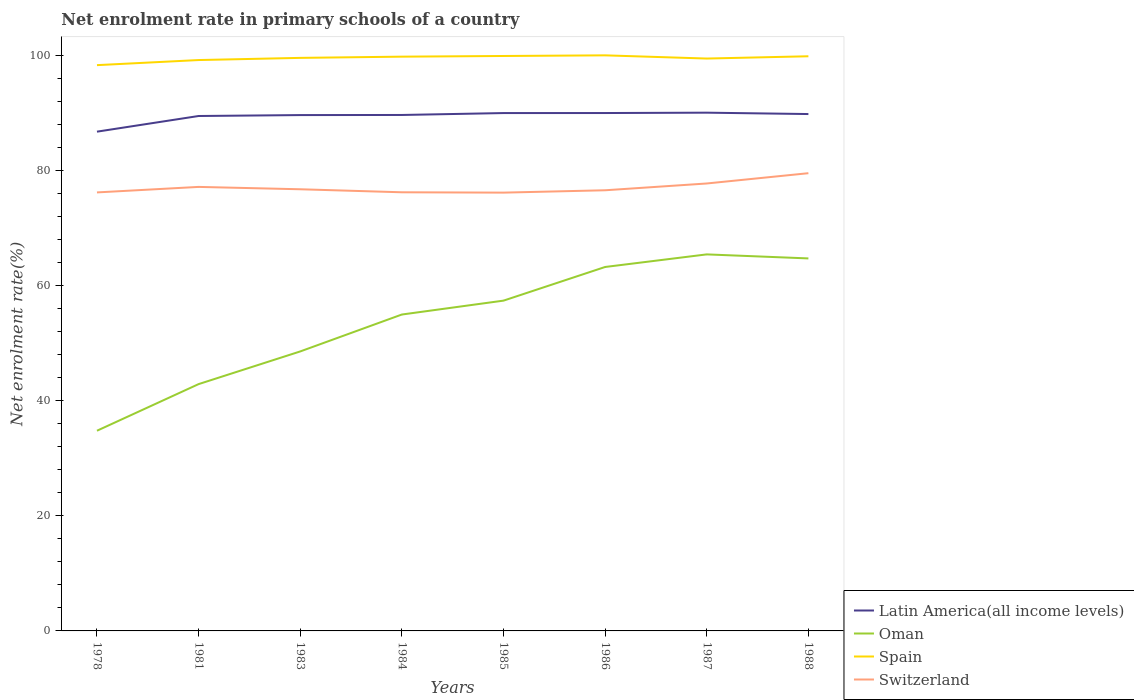Does the line corresponding to Switzerland intersect with the line corresponding to Latin America(all income levels)?
Provide a short and direct response. No. Across all years, what is the maximum net enrolment rate in primary schools in Spain?
Provide a short and direct response. 98.29. In which year was the net enrolment rate in primary schools in Spain maximum?
Offer a very short reply. 1978. What is the total net enrolment rate in primary schools in Switzerland in the graph?
Provide a short and direct response. -0.35. What is the difference between the highest and the second highest net enrolment rate in primary schools in Switzerland?
Provide a short and direct response. 3.38. What is the difference between the highest and the lowest net enrolment rate in primary schools in Switzerland?
Your answer should be very brief. 3. Is the net enrolment rate in primary schools in Spain strictly greater than the net enrolment rate in primary schools in Switzerland over the years?
Your answer should be very brief. No. How many lines are there?
Make the answer very short. 4. How many years are there in the graph?
Your response must be concise. 8. Does the graph contain any zero values?
Offer a terse response. No. Where does the legend appear in the graph?
Provide a short and direct response. Bottom right. What is the title of the graph?
Make the answer very short. Net enrolment rate in primary schools of a country. Does "Guinea" appear as one of the legend labels in the graph?
Your response must be concise. No. What is the label or title of the X-axis?
Offer a very short reply. Years. What is the label or title of the Y-axis?
Give a very brief answer. Net enrolment rate(%). What is the Net enrolment rate(%) of Latin America(all income levels) in 1978?
Give a very brief answer. 86.74. What is the Net enrolment rate(%) of Oman in 1978?
Offer a very short reply. 34.78. What is the Net enrolment rate(%) in Spain in 1978?
Provide a short and direct response. 98.29. What is the Net enrolment rate(%) in Switzerland in 1978?
Your answer should be very brief. 76.18. What is the Net enrolment rate(%) in Latin America(all income levels) in 1981?
Your answer should be compact. 89.46. What is the Net enrolment rate(%) of Oman in 1981?
Your answer should be very brief. 42.88. What is the Net enrolment rate(%) in Spain in 1981?
Ensure brevity in your answer.  99.18. What is the Net enrolment rate(%) of Switzerland in 1981?
Keep it short and to the point. 77.14. What is the Net enrolment rate(%) of Latin America(all income levels) in 1983?
Your answer should be compact. 89.62. What is the Net enrolment rate(%) in Oman in 1983?
Ensure brevity in your answer.  48.55. What is the Net enrolment rate(%) in Spain in 1983?
Your response must be concise. 99.56. What is the Net enrolment rate(%) in Switzerland in 1983?
Your response must be concise. 76.73. What is the Net enrolment rate(%) in Latin America(all income levels) in 1984?
Provide a short and direct response. 89.64. What is the Net enrolment rate(%) of Oman in 1984?
Offer a very short reply. 54.97. What is the Net enrolment rate(%) of Spain in 1984?
Give a very brief answer. 99.77. What is the Net enrolment rate(%) of Switzerland in 1984?
Give a very brief answer. 76.21. What is the Net enrolment rate(%) of Latin America(all income levels) in 1985?
Provide a succinct answer. 89.97. What is the Net enrolment rate(%) of Oman in 1985?
Offer a very short reply. 57.38. What is the Net enrolment rate(%) of Spain in 1985?
Ensure brevity in your answer.  99.89. What is the Net enrolment rate(%) in Switzerland in 1985?
Keep it short and to the point. 76.15. What is the Net enrolment rate(%) of Latin America(all income levels) in 1986?
Offer a very short reply. 89.98. What is the Net enrolment rate(%) in Oman in 1986?
Make the answer very short. 63.23. What is the Net enrolment rate(%) of Spain in 1986?
Make the answer very short. 100. What is the Net enrolment rate(%) in Switzerland in 1986?
Your answer should be compact. 76.56. What is the Net enrolment rate(%) of Latin America(all income levels) in 1987?
Ensure brevity in your answer.  90.04. What is the Net enrolment rate(%) in Oman in 1987?
Your answer should be very brief. 65.42. What is the Net enrolment rate(%) in Spain in 1987?
Provide a short and direct response. 99.44. What is the Net enrolment rate(%) in Switzerland in 1987?
Provide a short and direct response. 77.74. What is the Net enrolment rate(%) of Latin America(all income levels) in 1988?
Your answer should be very brief. 89.8. What is the Net enrolment rate(%) of Oman in 1988?
Offer a very short reply. 64.72. What is the Net enrolment rate(%) of Spain in 1988?
Ensure brevity in your answer.  99.84. What is the Net enrolment rate(%) of Switzerland in 1988?
Your answer should be compact. 79.52. Across all years, what is the maximum Net enrolment rate(%) of Latin America(all income levels)?
Your answer should be compact. 90.04. Across all years, what is the maximum Net enrolment rate(%) of Oman?
Provide a short and direct response. 65.42. Across all years, what is the maximum Net enrolment rate(%) in Spain?
Give a very brief answer. 100. Across all years, what is the maximum Net enrolment rate(%) in Switzerland?
Give a very brief answer. 79.52. Across all years, what is the minimum Net enrolment rate(%) of Latin America(all income levels)?
Provide a succinct answer. 86.74. Across all years, what is the minimum Net enrolment rate(%) in Oman?
Ensure brevity in your answer.  34.78. Across all years, what is the minimum Net enrolment rate(%) in Spain?
Offer a very short reply. 98.29. Across all years, what is the minimum Net enrolment rate(%) in Switzerland?
Your response must be concise. 76.15. What is the total Net enrolment rate(%) of Latin America(all income levels) in the graph?
Ensure brevity in your answer.  715.24. What is the total Net enrolment rate(%) in Oman in the graph?
Offer a very short reply. 431.93. What is the total Net enrolment rate(%) in Spain in the graph?
Keep it short and to the point. 795.97. What is the total Net enrolment rate(%) in Switzerland in the graph?
Provide a short and direct response. 616.22. What is the difference between the Net enrolment rate(%) in Latin America(all income levels) in 1978 and that in 1981?
Keep it short and to the point. -2.72. What is the difference between the Net enrolment rate(%) in Oman in 1978 and that in 1981?
Offer a terse response. -8.1. What is the difference between the Net enrolment rate(%) of Spain in 1978 and that in 1981?
Provide a succinct answer. -0.89. What is the difference between the Net enrolment rate(%) of Switzerland in 1978 and that in 1981?
Your answer should be very brief. -0.96. What is the difference between the Net enrolment rate(%) in Latin America(all income levels) in 1978 and that in 1983?
Provide a short and direct response. -2.88. What is the difference between the Net enrolment rate(%) in Oman in 1978 and that in 1983?
Make the answer very short. -13.78. What is the difference between the Net enrolment rate(%) in Spain in 1978 and that in 1983?
Your answer should be compact. -1.26. What is the difference between the Net enrolment rate(%) of Switzerland in 1978 and that in 1983?
Make the answer very short. -0.55. What is the difference between the Net enrolment rate(%) in Latin America(all income levels) in 1978 and that in 1984?
Make the answer very short. -2.9. What is the difference between the Net enrolment rate(%) of Oman in 1978 and that in 1984?
Your response must be concise. -20.19. What is the difference between the Net enrolment rate(%) of Spain in 1978 and that in 1984?
Give a very brief answer. -1.48. What is the difference between the Net enrolment rate(%) in Switzerland in 1978 and that in 1984?
Your response must be concise. -0.02. What is the difference between the Net enrolment rate(%) in Latin America(all income levels) in 1978 and that in 1985?
Ensure brevity in your answer.  -3.23. What is the difference between the Net enrolment rate(%) in Oman in 1978 and that in 1985?
Offer a very short reply. -22.6. What is the difference between the Net enrolment rate(%) of Spain in 1978 and that in 1985?
Make the answer very short. -1.59. What is the difference between the Net enrolment rate(%) of Switzerland in 1978 and that in 1985?
Your response must be concise. 0.04. What is the difference between the Net enrolment rate(%) in Latin America(all income levels) in 1978 and that in 1986?
Provide a succinct answer. -3.24. What is the difference between the Net enrolment rate(%) in Oman in 1978 and that in 1986?
Your answer should be very brief. -28.45. What is the difference between the Net enrolment rate(%) of Spain in 1978 and that in 1986?
Give a very brief answer. -1.7. What is the difference between the Net enrolment rate(%) in Switzerland in 1978 and that in 1986?
Provide a succinct answer. -0.37. What is the difference between the Net enrolment rate(%) in Latin America(all income levels) in 1978 and that in 1987?
Provide a short and direct response. -3.3. What is the difference between the Net enrolment rate(%) in Oman in 1978 and that in 1987?
Provide a short and direct response. -30.64. What is the difference between the Net enrolment rate(%) in Spain in 1978 and that in 1987?
Offer a very short reply. -1.15. What is the difference between the Net enrolment rate(%) in Switzerland in 1978 and that in 1987?
Ensure brevity in your answer.  -1.55. What is the difference between the Net enrolment rate(%) in Latin America(all income levels) in 1978 and that in 1988?
Your answer should be compact. -3.06. What is the difference between the Net enrolment rate(%) of Oman in 1978 and that in 1988?
Provide a short and direct response. -29.94. What is the difference between the Net enrolment rate(%) of Spain in 1978 and that in 1988?
Make the answer very short. -1.54. What is the difference between the Net enrolment rate(%) of Switzerland in 1978 and that in 1988?
Offer a very short reply. -3.34. What is the difference between the Net enrolment rate(%) of Latin America(all income levels) in 1981 and that in 1983?
Keep it short and to the point. -0.16. What is the difference between the Net enrolment rate(%) of Oman in 1981 and that in 1983?
Your answer should be compact. -5.68. What is the difference between the Net enrolment rate(%) in Spain in 1981 and that in 1983?
Your answer should be very brief. -0.38. What is the difference between the Net enrolment rate(%) in Switzerland in 1981 and that in 1983?
Provide a succinct answer. 0.41. What is the difference between the Net enrolment rate(%) of Latin America(all income levels) in 1981 and that in 1984?
Offer a terse response. -0.18. What is the difference between the Net enrolment rate(%) of Oman in 1981 and that in 1984?
Provide a succinct answer. -12.09. What is the difference between the Net enrolment rate(%) of Spain in 1981 and that in 1984?
Your answer should be very brief. -0.59. What is the difference between the Net enrolment rate(%) of Switzerland in 1981 and that in 1984?
Your response must be concise. 0.93. What is the difference between the Net enrolment rate(%) of Latin America(all income levels) in 1981 and that in 1985?
Your answer should be compact. -0.51. What is the difference between the Net enrolment rate(%) in Oman in 1981 and that in 1985?
Your response must be concise. -14.5. What is the difference between the Net enrolment rate(%) in Spain in 1981 and that in 1985?
Offer a very short reply. -0.71. What is the difference between the Net enrolment rate(%) of Switzerland in 1981 and that in 1985?
Provide a succinct answer. 0.99. What is the difference between the Net enrolment rate(%) in Latin America(all income levels) in 1981 and that in 1986?
Give a very brief answer. -0.52. What is the difference between the Net enrolment rate(%) of Oman in 1981 and that in 1986?
Provide a succinct answer. -20.35. What is the difference between the Net enrolment rate(%) of Spain in 1981 and that in 1986?
Your answer should be compact. -0.82. What is the difference between the Net enrolment rate(%) in Switzerland in 1981 and that in 1986?
Provide a succinct answer. 0.58. What is the difference between the Net enrolment rate(%) in Latin America(all income levels) in 1981 and that in 1987?
Provide a short and direct response. -0.58. What is the difference between the Net enrolment rate(%) in Oman in 1981 and that in 1987?
Keep it short and to the point. -22.54. What is the difference between the Net enrolment rate(%) of Spain in 1981 and that in 1987?
Offer a very short reply. -0.26. What is the difference between the Net enrolment rate(%) in Switzerland in 1981 and that in 1987?
Keep it short and to the point. -0.6. What is the difference between the Net enrolment rate(%) of Latin America(all income levels) in 1981 and that in 1988?
Make the answer very short. -0.34. What is the difference between the Net enrolment rate(%) in Oman in 1981 and that in 1988?
Your response must be concise. -21.84. What is the difference between the Net enrolment rate(%) in Spain in 1981 and that in 1988?
Make the answer very short. -0.66. What is the difference between the Net enrolment rate(%) in Switzerland in 1981 and that in 1988?
Make the answer very short. -2.38. What is the difference between the Net enrolment rate(%) of Latin America(all income levels) in 1983 and that in 1984?
Your answer should be very brief. -0.02. What is the difference between the Net enrolment rate(%) of Oman in 1983 and that in 1984?
Offer a very short reply. -6.41. What is the difference between the Net enrolment rate(%) of Spain in 1983 and that in 1984?
Offer a very short reply. -0.21. What is the difference between the Net enrolment rate(%) in Switzerland in 1983 and that in 1984?
Provide a succinct answer. 0.52. What is the difference between the Net enrolment rate(%) in Latin America(all income levels) in 1983 and that in 1985?
Your answer should be very brief. -0.35. What is the difference between the Net enrolment rate(%) in Oman in 1983 and that in 1985?
Make the answer very short. -8.83. What is the difference between the Net enrolment rate(%) in Spain in 1983 and that in 1985?
Ensure brevity in your answer.  -0.33. What is the difference between the Net enrolment rate(%) in Switzerland in 1983 and that in 1985?
Give a very brief answer. 0.58. What is the difference between the Net enrolment rate(%) of Latin America(all income levels) in 1983 and that in 1986?
Your response must be concise. -0.36. What is the difference between the Net enrolment rate(%) in Oman in 1983 and that in 1986?
Provide a succinct answer. -14.67. What is the difference between the Net enrolment rate(%) of Spain in 1983 and that in 1986?
Ensure brevity in your answer.  -0.44. What is the difference between the Net enrolment rate(%) in Switzerland in 1983 and that in 1986?
Ensure brevity in your answer.  0.18. What is the difference between the Net enrolment rate(%) in Latin America(all income levels) in 1983 and that in 1987?
Your answer should be very brief. -0.42. What is the difference between the Net enrolment rate(%) of Oman in 1983 and that in 1987?
Keep it short and to the point. -16.86. What is the difference between the Net enrolment rate(%) in Spain in 1983 and that in 1987?
Offer a very short reply. 0.12. What is the difference between the Net enrolment rate(%) of Switzerland in 1983 and that in 1987?
Provide a succinct answer. -1. What is the difference between the Net enrolment rate(%) of Latin America(all income levels) in 1983 and that in 1988?
Your answer should be very brief. -0.18. What is the difference between the Net enrolment rate(%) of Oman in 1983 and that in 1988?
Your answer should be very brief. -16.16. What is the difference between the Net enrolment rate(%) in Spain in 1983 and that in 1988?
Give a very brief answer. -0.28. What is the difference between the Net enrolment rate(%) of Switzerland in 1983 and that in 1988?
Keep it short and to the point. -2.79. What is the difference between the Net enrolment rate(%) of Latin America(all income levels) in 1984 and that in 1985?
Your response must be concise. -0.33. What is the difference between the Net enrolment rate(%) of Oman in 1984 and that in 1985?
Give a very brief answer. -2.41. What is the difference between the Net enrolment rate(%) of Spain in 1984 and that in 1985?
Give a very brief answer. -0.12. What is the difference between the Net enrolment rate(%) of Switzerland in 1984 and that in 1985?
Your response must be concise. 0.06. What is the difference between the Net enrolment rate(%) of Latin America(all income levels) in 1984 and that in 1986?
Your response must be concise. -0.34. What is the difference between the Net enrolment rate(%) of Oman in 1984 and that in 1986?
Ensure brevity in your answer.  -8.26. What is the difference between the Net enrolment rate(%) in Spain in 1984 and that in 1986?
Ensure brevity in your answer.  -0.23. What is the difference between the Net enrolment rate(%) in Switzerland in 1984 and that in 1986?
Offer a terse response. -0.35. What is the difference between the Net enrolment rate(%) of Latin America(all income levels) in 1984 and that in 1987?
Offer a very short reply. -0.4. What is the difference between the Net enrolment rate(%) of Oman in 1984 and that in 1987?
Ensure brevity in your answer.  -10.45. What is the difference between the Net enrolment rate(%) of Spain in 1984 and that in 1987?
Provide a succinct answer. 0.33. What is the difference between the Net enrolment rate(%) in Switzerland in 1984 and that in 1987?
Your answer should be compact. -1.53. What is the difference between the Net enrolment rate(%) of Latin America(all income levels) in 1984 and that in 1988?
Your answer should be compact. -0.16. What is the difference between the Net enrolment rate(%) in Oman in 1984 and that in 1988?
Your response must be concise. -9.75. What is the difference between the Net enrolment rate(%) in Spain in 1984 and that in 1988?
Provide a succinct answer. -0.07. What is the difference between the Net enrolment rate(%) in Switzerland in 1984 and that in 1988?
Ensure brevity in your answer.  -3.32. What is the difference between the Net enrolment rate(%) of Latin America(all income levels) in 1985 and that in 1986?
Ensure brevity in your answer.  -0. What is the difference between the Net enrolment rate(%) of Oman in 1985 and that in 1986?
Your answer should be compact. -5.85. What is the difference between the Net enrolment rate(%) of Spain in 1985 and that in 1986?
Offer a terse response. -0.11. What is the difference between the Net enrolment rate(%) of Switzerland in 1985 and that in 1986?
Provide a short and direct response. -0.41. What is the difference between the Net enrolment rate(%) of Latin America(all income levels) in 1985 and that in 1987?
Give a very brief answer. -0.07. What is the difference between the Net enrolment rate(%) of Oman in 1985 and that in 1987?
Give a very brief answer. -8.04. What is the difference between the Net enrolment rate(%) in Spain in 1985 and that in 1987?
Provide a succinct answer. 0.45. What is the difference between the Net enrolment rate(%) in Switzerland in 1985 and that in 1987?
Keep it short and to the point. -1.59. What is the difference between the Net enrolment rate(%) in Latin America(all income levels) in 1985 and that in 1988?
Keep it short and to the point. 0.17. What is the difference between the Net enrolment rate(%) of Oman in 1985 and that in 1988?
Your response must be concise. -7.34. What is the difference between the Net enrolment rate(%) in Spain in 1985 and that in 1988?
Keep it short and to the point. 0.05. What is the difference between the Net enrolment rate(%) in Switzerland in 1985 and that in 1988?
Offer a terse response. -3.38. What is the difference between the Net enrolment rate(%) in Latin America(all income levels) in 1986 and that in 1987?
Your answer should be compact. -0.06. What is the difference between the Net enrolment rate(%) in Oman in 1986 and that in 1987?
Provide a succinct answer. -2.19. What is the difference between the Net enrolment rate(%) in Spain in 1986 and that in 1987?
Your answer should be very brief. 0.56. What is the difference between the Net enrolment rate(%) of Switzerland in 1986 and that in 1987?
Give a very brief answer. -1.18. What is the difference between the Net enrolment rate(%) in Latin America(all income levels) in 1986 and that in 1988?
Provide a succinct answer. 0.18. What is the difference between the Net enrolment rate(%) in Oman in 1986 and that in 1988?
Your response must be concise. -1.49. What is the difference between the Net enrolment rate(%) of Spain in 1986 and that in 1988?
Ensure brevity in your answer.  0.16. What is the difference between the Net enrolment rate(%) in Switzerland in 1986 and that in 1988?
Your response must be concise. -2.97. What is the difference between the Net enrolment rate(%) in Latin America(all income levels) in 1987 and that in 1988?
Provide a succinct answer. 0.24. What is the difference between the Net enrolment rate(%) in Oman in 1987 and that in 1988?
Your answer should be compact. 0.7. What is the difference between the Net enrolment rate(%) in Spain in 1987 and that in 1988?
Provide a succinct answer. -0.4. What is the difference between the Net enrolment rate(%) of Switzerland in 1987 and that in 1988?
Give a very brief answer. -1.79. What is the difference between the Net enrolment rate(%) in Latin America(all income levels) in 1978 and the Net enrolment rate(%) in Oman in 1981?
Provide a short and direct response. 43.86. What is the difference between the Net enrolment rate(%) of Latin America(all income levels) in 1978 and the Net enrolment rate(%) of Spain in 1981?
Your answer should be compact. -12.44. What is the difference between the Net enrolment rate(%) of Latin America(all income levels) in 1978 and the Net enrolment rate(%) of Switzerland in 1981?
Give a very brief answer. 9.6. What is the difference between the Net enrolment rate(%) in Oman in 1978 and the Net enrolment rate(%) in Spain in 1981?
Provide a succinct answer. -64.4. What is the difference between the Net enrolment rate(%) of Oman in 1978 and the Net enrolment rate(%) of Switzerland in 1981?
Your answer should be very brief. -42.36. What is the difference between the Net enrolment rate(%) in Spain in 1978 and the Net enrolment rate(%) in Switzerland in 1981?
Your response must be concise. 21.16. What is the difference between the Net enrolment rate(%) in Latin America(all income levels) in 1978 and the Net enrolment rate(%) in Oman in 1983?
Provide a short and direct response. 38.18. What is the difference between the Net enrolment rate(%) in Latin America(all income levels) in 1978 and the Net enrolment rate(%) in Spain in 1983?
Offer a very short reply. -12.82. What is the difference between the Net enrolment rate(%) of Latin America(all income levels) in 1978 and the Net enrolment rate(%) of Switzerland in 1983?
Offer a very short reply. 10.01. What is the difference between the Net enrolment rate(%) in Oman in 1978 and the Net enrolment rate(%) in Spain in 1983?
Keep it short and to the point. -64.78. What is the difference between the Net enrolment rate(%) in Oman in 1978 and the Net enrolment rate(%) in Switzerland in 1983?
Keep it short and to the point. -41.95. What is the difference between the Net enrolment rate(%) of Spain in 1978 and the Net enrolment rate(%) of Switzerland in 1983?
Give a very brief answer. 21.56. What is the difference between the Net enrolment rate(%) in Latin America(all income levels) in 1978 and the Net enrolment rate(%) in Oman in 1984?
Your response must be concise. 31.77. What is the difference between the Net enrolment rate(%) of Latin America(all income levels) in 1978 and the Net enrolment rate(%) of Spain in 1984?
Your response must be concise. -13.03. What is the difference between the Net enrolment rate(%) in Latin America(all income levels) in 1978 and the Net enrolment rate(%) in Switzerland in 1984?
Your answer should be very brief. 10.53. What is the difference between the Net enrolment rate(%) of Oman in 1978 and the Net enrolment rate(%) of Spain in 1984?
Provide a short and direct response. -64.99. What is the difference between the Net enrolment rate(%) in Oman in 1978 and the Net enrolment rate(%) in Switzerland in 1984?
Ensure brevity in your answer.  -41.43. What is the difference between the Net enrolment rate(%) in Spain in 1978 and the Net enrolment rate(%) in Switzerland in 1984?
Offer a very short reply. 22.09. What is the difference between the Net enrolment rate(%) of Latin America(all income levels) in 1978 and the Net enrolment rate(%) of Oman in 1985?
Give a very brief answer. 29.36. What is the difference between the Net enrolment rate(%) of Latin America(all income levels) in 1978 and the Net enrolment rate(%) of Spain in 1985?
Give a very brief answer. -13.15. What is the difference between the Net enrolment rate(%) of Latin America(all income levels) in 1978 and the Net enrolment rate(%) of Switzerland in 1985?
Make the answer very short. 10.59. What is the difference between the Net enrolment rate(%) of Oman in 1978 and the Net enrolment rate(%) of Spain in 1985?
Make the answer very short. -65.11. What is the difference between the Net enrolment rate(%) in Oman in 1978 and the Net enrolment rate(%) in Switzerland in 1985?
Ensure brevity in your answer.  -41.37. What is the difference between the Net enrolment rate(%) of Spain in 1978 and the Net enrolment rate(%) of Switzerland in 1985?
Give a very brief answer. 22.15. What is the difference between the Net enrolment rate(%) of Latin America(all income levels) in 1978 and the Net enrolment rate(%) of Oman in 1986?
Your response must be concise. 23.51. What is the difference between the Net enrolment rate(%) of Latin America(all income levels) in 1978 and the Net enrolment rate(%) of Spain in 1986?
Make the answer very short. -13.26. What is the difference between the Net enrolment rate(%) of Latin America(all income levels) in 1978 and the Net enrolment rate(%) of Switzerland in 1986?
Keep it short and to the point. 10.18. What is the difference between the Net enrolment rate(%) of Oman in 1978 and the Net enrolment rate(%) of Spain in 1986?
Your response must be concise. -65.22. What is the difference between the Net enrolment rate(%) in Oman in 1978 and the Net enrolment rate(%) in Switzerland in 1986?
Give a very brief answer. -41.78. What is the difference between the Net enrolment rate(%) in Spain in 1978 and the Net enrolment rate(%) in Switzerland in 1986?
Ensure brevity in your answer.  21.74. What is the difference between the Net enrolment rate(%) in Latin America(all income levels) in 1978 and the Net enrolment rate(%) in Oman in 1987?
Your answer should be very brief. 21.32. What is the difference between the Net enrolment rate(%) of Latin America(all income levels) in 1978 and the Net enrolment rate(%) of Spain in 1987?
Your response must be concise. -12.7. What is the difference between the Net enrolment rate(%) of Latin America(all income levels) in 1978 and the Net enrolment rate(%) of Switzerland in 1987?
Provide a succinct answer. 9. What is the difference between the Net enrolment rate(%) in Oman in 1978 and the Net enrolment rate(%) in Spain in 1987?
Provide a succinct answer. -64.66. What is the difference between the Net enrolment rate(%) in Oman in 1978 and the Net enrolment rate(%) in Switzerland in 1987?
Make the answer very short. -42.96. What is the difference between the Net enrolment rate(%) of Spain in 1978 and the Net enrolment rate(%) of Switzerland in 1987?
Your answer should be compact. 20.56. What is the difference between the Net enrolment rate(%) in Latin America(all income levels) in 1978 and the Net enrolment rate(%) in Oman in 1988?
Give a very brief answer. 22.02. What is the difference between the Net enrolment rate(%) of Latin America(all income levels) in 1978 and the Net enrolment rate(%) of Spain in 1988?
Provide a succinct answer. -13.1. What is the difference between the Net enrolment rate(%) in Latin America(all income levels) in 1978 and the Net enrolment rate(%) in Switzerland in 1988?
Provide a short and direct response. 7.21. What is the difference between the Net enrolment rate(%) of Oman in 1978 and the Net enrolment rate(%) of Spain in 1988?
Your answer should be compact. -65.06. What is the difference between the Net enrolment rate(%) in Oman in 1978 and the Net enrolment rate(%) in Switzerland in 1988?
Provide a short and direct response. -44.74. What is the difference between the Net enrolment rate(%) of Spain in 1978 and the Net enrolment rate(%) of Switzerland in 1988?
Give a very brief answer. 18.77. What is the difference between the Net enrolment rate(%) in Latin America(all income levels) in 1981 and the Net enrolment rate(%) in Oman in 1983?
Your answer should be very brief. 40.9. What is the difference between the Net enrolment rate(%) in Latin America(all income levels) in 1981 and the Net enrolment rate(%) in Spain in 1983?
Give a very brief answer. -10.1. What is the difference between the Net enrolment rate(%) in Latin America(all income levels) in 1981 and the Net enrolment rate(%) in Switzerland in 1983?
Offer a very short reply. 12.73. What is the difference between the Net enrolment rate(%) in Oman in 1981 and the Net enrolment rate(%) in Spain in 1983?
Make the answer very short. -56.68. What is the difference between the Net enrolment rate(%) in Oman in 1981 and the Net enrolment rate(%) in Switzerland in 1983?
Keep it short and to the point. -33.85. What is the difference between the Net enrolment rate(%) of Spain in 1981 and the Net enrolment rate(%) of Switzerland in 1983?
Provide a succinct answer. 22.45. What is the difference between the Net enrolment rate(%) of Latin America(all income levels) in 1981 and the Net enrolment rate(%) of Oman in 1984?
Offer a terse response. 34.49. What is the difference between the Net enrolment rate(%) of Latin America(all income levels) in 1981 and the Net enrolment rate(%) of Spain in 1984?
Your answer should be very brief. -10.31. What is the difference between the Net enrolment rate(%) of Latin America(all income levels) in 1981 and the Net enrolment rate(%) of Switzerland in 1984?
Offer a terse response. 13.25. What is the difference between the Net enrolment rate(%) in Oman in 1981 and the Net enrolment rate(%) in Spain in 1984?
Ensure brevity in your answer.  -56.89. What is the difference between the Net enrolment rate(%) of Oman in 1981 and the Net enrolment rate(%) of Switzerland in 1984?
Provide a short and direct response. -33.33. What is the difference between the Net enrolment rate(%) in Spain in 1981 and the Net enrolment rate(%) in Switzerland in 1984?
Your response must be concise. 22.97. What is the difference between the Net enrolment rate(%) in Latin America(all income levels) in 1981 and the Net enrolment rate(%) in Oman in 1985?
Offer a terse response. 32.08. What is the difference between the Net enrolment rate(%) in Latin America(all income levels) in 1981 and the Net enrolment rate(%) in Spain in 1985?
Ensure brevity in your answer.  -10.43. What is the difference between the Net enrolment rate(%) in Latin America(all income levels) in 1981 and the Net enrolment rate(%) in Switzerland in 1985?
Ensure brevity in your answer.  13.31. What is the difference between the Net enrolment rate(%) in Oman in 1981 and the Net enrolment rate(%) in Spain in 1985?
Your answer should be very brief. -57.01. What is the difference between the Net enrolment rate(%) in Oman in 1981 and the Net enrolment rate(%) in Switzerland in 1985?
Offer a very short reply. -33.27. What is the difference between the Net enrolment rate(%) in Spain in 1981 and the Net enrolment rate(%) in Switzerland in 1985?
Offer a terse response. 23.03. What is the difference between the Net enrolment rate(%) of Latin America(all income levels) in 1981 and the Net enrolment rate(%) of Oman in 1986?
Ensure brevity in your answer.  26.23. What is the difference between the Net enrolment rate(%) of Latin America(all income levels) in 1981 and the Net enrolment rate(%) of Spain in 1986?
Keep it short and to the point. -10.54. What is the difference between the Net enrolment rate(%) of Latin America(all income levels) in 1981 and the Net enrolment rate(%) of Switzerland in 1986?
Your answer should be very brief. 12.9. What is the difference between the Net enrolment rate(%) of Oman in 1981 and the Net enrolment rate(%) of Spain in 1986?
Your answer should be compact. -57.12. What is the difference between the Net enrolment rate(%) of Oman in 1981 and the Net enrolment rate(%) of Switzerland in 1986?
Give a very brief answer. -33.68. What is the difference between the Net enrolment rate(%) in Spain in 1981 and the Net enrolment rate(%) in Switzerland in 1986?
Give a very brief answer. 22.62. What is the difference between the Net enrolment rate(%) in Latin America(all income levels) in 1981 and the Net enrolment rate(%) in Oman in 1987?
Make the answer very short. 24.04. What is the difference between the Net enrolment rate(%) of Latin America(all income levels) in 1981 and the Net enrolment rate(%) of Spain in 1987?
Provide a short and direct response. -9.98. What is the difference between the Net enrolment rate(%) of Latin America(all income levels) in 1981 and the Net enrolment rate(%) of Switzerland in 1987?
Your response must be concise. 11.72. What is the difference between the Net enrolment rate(%) in Oman in 1981 and the Net enrolment rate(%) in Spain in 1987?
Provide a succinct answer. -56.56. What is the difference between the Net enrolment rate(%) in Oman in 1981 and the Net enrolment rate(%) in Switzerland in 1987?
Make the answer very short. -34.86. What is the difference between the Net enrolment rate(%) in Spain in 1981 and the Net enrolment rate(%) in Switzerland in 1987?
Keep it short and to the point. 21.44. What is the difference between the Net enrolment rate(%) in Latin America(all income levels) in 1981 and the Net enrolment rate(%) in Oman in 1988?
Keep it short and to the point. 24.74. What is the difference between the Net enrolment rate(%) of Latin America(all income levels) in 1981 and the Net enrolment rate(%) of Spain in 1988?
Ensure brevity in your answer.  -10.38. What is the difference between the Net enrolment rate(%) of Latin America(all income levels) in 1981 and the Net enrolment rate(%) of Switzerland in 1988?
Offer a very short reply. 9.94. What is the difference between the Net enrolment rate(%) in Oman in 1981 and the Net enrolment rate(%) in Spain in 1988?
Make the answer very short. -56.96. What is the difference between the Net enrolment rate(%) of Oman in 1981 and the Net enrolment rate(%) of Switzerland in 1988?
Keep it short and to the point. -36.64. What is the difference between the Net enrolment rate(%) of Spain in 1981 and the Net enrolment rate(%) of Switzerland in 1988?
Make the answer very short. 19.66. What is the difference between the Net enrolment rate(%) of Latin America(all income levels) in 1983 and the Net enrolment rate(%) of Oman in 1984?
Ensure brevity in your answer.  34.65. What is the difference between the Net enrolment rate(%) in Latin America(all income levels) in 1983 and the Net enrolment rate(%) in Spain in 1984?
Keep it short and to the point. -10.15. What is the difference between the Net enrolment rate(%) in Latin America(all income levels) in 1983 and the Net enrolment rate(%) in Switzerland in 1984?
Your answer should be compact. 13.41. What is the difference between the Net enrolment rate(%) of Oman in 1983 and the Net enrolment rate(%) of Spain in 1984?
Ensure brevity in your answer.  -51.22. What is the difference between the Net enrolment rate(%) in Oman in 1983 and the Net enrolment rate(%) in Switzerland in 1984?
Make the answer very short. -27.65. What is the difference between the Net enrolment rate(%) of Spain in 1983 and the Net enrolment rate(%) of Switzerland in 1984?
Offer a terse response. 23.35. What is the difference between the Net enrolment rate(%) of Latin America(all income levels) in 1983 and the Net enrolment rate(%) of Oman in 1985?
Your answer should be very brief. 32.24. What is the difference between the Net enrolment rate(%) of Latin America(all income levels) in 1983 and the Net enrolment rate(%) of Spain in 1985?
Offer a very short reply. -10.27. What is the difference between the Net enrolment rate(%) in Latin America(all income levels) in 1983 and the Net enrolment rate(%) in Switzerland in 1985?
Provide a succinct answer. 13.47. What is the difference between the Net enrolment rate(%) of Oman in 1983 and the Net enrolment rate(%) of Spain in 1985?
Offer a terse response. -51.33. What is the difference between the Net enrolment rate(%) of Oman in 1983 and the Net enrolment rate(%) of Switzerland in 1985?
Your response must be concise. -27.59. What is the difference between the Net enrolment rate(%) of Spain in 1983 and the Net enrolment rate(%) of Switzerland in 1985?
Ensure brevity in your answer.  23.41. What is the difference between the Net enrolment rate(%) of Latin America(all income levels) in 1983 and the Net enrolment rate(%) of Oman in 1986?
Provide a succinct answer. 26.39. What is the difference between the Net enrolment rate(%) of Latin America(all income levels) in 1983 and the Net enrolment rate(%) of Spain in 1986?
Your answer should be compact. -10.38. What is the difference between the Net enrolment rate(%) of Latin America(all income levels) in 1983 and the Net enrolment rate(%) of Switzerland in 1986?
Offer a terse response. 13.06. What is the difference between the Net enrolment rate(%) of Oman in 1983 and the Net enrolment rate(%) of Spain in 1986?
Provide a short and direct response. -51.44. What is the difference between the Net enrolment rate(%) of Oman in 1983 and the Net enrolment rate(%) of Switzerland in 1986?
Offer a terse response. -28. What is the difference between the Net enrolment rate(%) in Spain in 1983 and the Net enrolment rate(%) in Switzerland in 1986?
Offer a terse response. 23. What is the difference between the Net enrolment rate(%) in Latin America(all income levels) in 1983 and the Net enrolment rate(%) in Oman in 1987?
Provide a succinct answer. 24.2. What is the difference between the Net enrolment rate(%) of Latin America(all income levels) in 1983 and the Net enrolment rate(%) of Spain in 1987?
Your answer should be very brief. -9.82. What is the difference between the Net enrolment rate(%) of Latin America(all income levels) in 1983 and the Net enrolment rate(%) of Switzerland in 1987?
Make the answer very short. 11.88. What is the difference between the Net enrolment rate(%) of Oman in 1983 and the Net enrolment rate(%) of Spain in 1987?
Give a very brief answer. -50.89. What is the difference between the Net enrolment rate(%) in Oman in 1983 and the Net enrolment rate(%) in Switzerland in 1987?
Make the answer very short. -29.18. What is the difference between the Net enrolment rate(%) of Spain in 1983 and the Net enrolment rate(%) of Switzerland in 1987?
Keep it short and to the point. 21.82. What is the difference between the Net enrolment rate(%) in Latin America(all income levels) in 1983 and the Net enrolment rate(%) in Oman in 1988?
Offer a very short reply. 24.9. What is the difference between the Net enrolment rate(%) in Latin America(all income levels) in 1983 and the Net enrolment rate(%) in Spain in 1988?
Make the answer very short. -10.22. What is the difference between the Net enrolment rate(%) in Latin America(all income levels) in 1983 and the Net enrolment rate(%) in Switzerland in 1988?
Offer a terse response. 10.1. What is the difference between the Net enrolment rate(%) in Oman in 1983 and the Net enrolment rate(%) in Spain in 1988?
Offer a very short reply. -51.28. What is the difference between the Net enrolment rate(%) in Oman in 1983 and the Net enrolment rate(%) in Switzerland in 1988?
Keep it short and to the point. -30.97. What is the difference between the Net enrolment rate(%) in Spain in 1983 and the Net enrolment rate(%) in Switzerland in 1988?
Provide a succinct answer. 20.04. What is the difference between the Net enrolment rate(%) in Latin America(all income levels) in 1984 and the Net enrolment rate(%) in Oman in 1985?
Your answer should be very brief. 32.26. What is the difference between the Net enrolment rate(%) in Latin America(all income levels) in 1984 and the Net enrolment rate(%) in Spain in 1985?
Offer a terse response. -10.25. What is the difference between the Net enrolment rate(%) of Latin America(all income levels) in 1984 and the Net enrolment rate(%) of Switzerland in 1985?
Your answer should be very brief. 13.49. What is the difference between the Net enrolment rate(%) of Oman in 1984 and the Net enrolment rate(%) of Spain in 1985?
Keep it short and to the point. -44.92. What is the difference between the Net enrolment rate(%) of Oman in 1984 and the Net enrolment rate(%) of Switzerland in 1985?
Keep it short and to the point. -21.18. What is the difference between the Net enrolment rate(%) of Spain in 1984 and the Net enrolment rate(%) of Switzerland in 1985?
Make the answer very short. 23.62. What is the difference between the Net enrolment rate(%) in Latin America(all income levels) in 1984 and the Net enrolment rate(%) in Oman in 1986?
Offer a very short reply. 26.41. What is the difference between the Net enrolment rate(%) in Latin America(all income levels) in 1984 and the Net enrolment rate(%) in Spain in 1986?
Offer a very short reply. -10.36. What is the difference between the Net enrolment rate(%) of Latin America(all income levels) in 1984 and the Net enrolment rate(%) of Switzerland in 1986?
Make the answer very short. 13.08. What is the difference between the Net enrolment rate(%) in Oman in 1984 and the Net enrolment rate(%) in Spain in 1986?
Your answer should be very brief. -45.03. What is the difference between the Net enrolment rate(%) in Oman in 1984 and the Net enrolment rate(%) in Switzerland in 1986?
Give a very brief answer. -21.59. What is the difference between the Net enrolment rate(%) of Spain in 1984 and the Net enrolment rate(%) of Switzerland in 1986?
Make the answer very short. 23.21. What is the difference between the Net enrolment rate(%) of Latin America(all income levels) in 1984 and the Net enrolment rate(%) of Oman in 1987?
Offer a terse response. 24.22. What is the difference between the Net enrolment rate(%) in Latin America(all income levels) in 1984 and the Net enrolment rate(%) in Spain in 1987?
Your answer should be very brief. -9.8. What is the difference between the Net enrolment rate(%) in Latin America(all income levels) in 1984 and the Net enrolment rate(%) in Switzerland in 1987?
Your response must be concise. 11.9. What is the difference between the Net enrolment rate(%) in Oman in 1984 and the Net enrolment rate(%) in Spain in 1987?
Provide a succinct answer. -44.47. What is the difference between the Net enrolment rate(%) of Oman in 1984 and the Net enrolment rate(%) of Switzerland in 1987?
Your answer should be compact. -22.77. What is the difference between the Net enrolment rate(%) in Spain in 1984 and the Net enrolment rate(%) in Switzerland in 1987?
Ensure brevity in your answer.  22.03. What is the difference between the Net enrolment rate(%) of Latin America(all income levels) in 1984 and the Net enrolment rate(%) of Oman in 1988?
Offer a terse response. 24.92. What is the difference between the Net enrolment rate(%) of Latin America(all income levels) in 1984 and the Net enrolment rate(%) of Spain in 1988?
Keep it short and to the point. -10.2. What is the difference between the Net enrolment rate(%) in Latin America(all income levels) in 1984 and the Net enrolment rate(%) in Switzerland in 1988?
Your response must be concise. 10.11. What is the difference between the Net enrolment rate(%) of Oman in 1984 and the Net enrolment rate(%) of Spain in 1988?
Offer a terse response. -44.87. What is the difference between the Net enrolment rate(%) in Oman in 1984 and the Net enrolment rate(%) in Switzerland in 1988?
Your answer should be compact. -24.55. What is the difference between the Net enrolment rate(%) of Spain in 1984 and the Net enrolment rate(%) of Switzerland in 1988?
Offer a terse response. 20.25. What is the difference between the Net enrolment rate(%) in Latin America(all income levels) in 1985 and the Net enrolment rate(%) in Oman in 1986?
Offer a very short reply. 26.74. What is the difference between the Net enrolment rate(%) of Latin America(all income levels) in 1985 and the Net enrolment rate(%) of Spain in 1986?
Provide a short and direct response. -10.03. What is the difference between the Net enrolment rate(%) of Latin America(all income levels) in 1985 and the Net enrolment rate(%) of Switzerland in 1986?
Give a very brief answer. 13.42. What is the difference between the Net enrolment rate(%) of Oman in 1985 and the Net enrolment rate(%) of Spain in 1986?
Make the answer very short. -42.62. What is the difference between the Net enrolment rate(%) in Oman in 1985 and the Net enrolment rate(%) in Switzerland in 1986?
Provide a short and direct response. -19.17. What is the difference between the Net enrolment rate(%) of Spain in 1985 and the Net enrolment rate(%) of Switzerland in 1986?
Keep it short and to the point. 23.33. What is the difference between the Net enrolment rate(%) of Latin America(all income levels) in 1985 and the Net enrolment rate(%) of Oman in 1987?
Give a very brief answer. 24.55. What is the difference between the Net enrolment rate(%) in Latin America(all income levels) in 1985 and the Net enrolment rate(%) in Spain in 1987?
Provide a short and direct response. -9.47. What is the difference between the Net enrolment rate(%) of Latin America(all income levels) in 1985 and the Net enrolment rate(%) of Switzerland in 1987?
Provide a succinct answer. 12.23. What is the difference between the Net enrolment rate(%) of Oman in 1985 and the Net enrolment rate(%) of Spain in 1987?
Provide a short and direct response. -42.06. What is the difference between the Net enrolment rate(%) in Oman in 1985 and the Net enrolment rate(%) in Switzerland in 1987?
Offer a terse response. -20.35. What is the difference between the Net enrolment rate(%) of Spain in 1985 and the Net enrolment rate(%) of Switzerland in 1987?
Your response must be concise. 22.15. What is the difference between the Net enrolment rate(%) of Latin America(all income levels) in 1985 and the Net enrolment rate(%) of Oman in 1988?
Give a very brief answer. 25.25. What is the difference between the Net enrolment rate(%) of Latin America(all income levels) in 1985 and the Net enrolment rate(%) of Spain in 1988?
Offer a very short reply. -9.87. What is the difference between the Net enrolment rate(%) in Latin America(all income levels) in 1985 and the Net enrolment rate(%) in Switzerland in 1988?
Make the answer very short. 10.45. What is the difference between the Net enrolment rate(%) of Oman in 1985 and the Net enrolment rate(%) of Spain in 1988?
Offer a very short reply. -42.46. What is the difference between the Net enrolment rate(%) in Oman in 1985 and the Net enrolment rate(%) in Switzerland in 1988?
Your answer should be very brief. -22.14. What is the difference between the Net enrolment rate(%) in Spain in 1985 and the Net enrolment rate(%) in Switzerland in 1988?
Your answer should be very brief. 20.36. What is the difference between the Net enrolment rate(%) in Latin America(all income levels) in 1986 and the Net enrolment rate(%) in Oman in 1987?
Provide a short and direct response. 24.56. What is the difference between the Net enrolment rate(%) in Latin America(all income levels) in 1986 and the Net enrolment rate(%) in Spain in 1987?
Provide a succinct answer. -9.47. What is the difference between the Net enrolment rate(%) of Latin America(all income levels) in 1986 and the Net enrolment rate(%) of Switzerland in 1987?
Your answer should be compact. 12.24. What is the difference between the Net enrolment rate(%) of Oman in 1986 and the Net enrolment rate(%) of Spain in 1987?
Offer a very short reply. -36.21. What is the difference between the Net enrolment rate(%) in Oman in 1986 and the Net enrolment rate(%) in Switzerland in 1987?
Provide a succinct answer. -14.51. What is the difference between the Net enrolment rate(%) in Spain in 1986 and the Net enrolment rate(%) in Switzerland in 1987?
Give a very brief answer. 22.26. What is the difference between the Net enrolment rate(%) in Latin America(all income levels) in 1986 and the Net enrolment rate(%) in Oman in 1988?
Give a very brief answer. 25.26. What is the difference between the Net enrolment rate(%) in Latin America(all income levels) in 1986 and the Net enrolment rate(%) in Spain in 1988?
Give a very brief answer. -9.86. What is the difference between the Net enrolment rate(%) in Latin America(all income levels) in 1986 and the Net enrolment rate(%) in Switzerland in 1988?
Offer a very short reply. 10.45. What is the difference between the Net enrolment rate(%) of Oman in 1986 and the Net enrolment rate(%) of Spain in 1988?
Your answer should be compact. -36.61. What is the difference between the Net enrolment rate(%) in Oman in 1986 and the Net enrolment rate(%) in Switzerland in 1988?
Give a very brief answer. -16.29. What is the difference between the Net enrolment rate(%) in Spain in 1986 and the Net enrolment rate(%) in Switzerland in 1988?
Provide a succinct answer. 20.47. What is the difference between the Net enrolment rate(%) of Latin America(all income levels) in 1987 and the Net enrolment rate(%) of Oman in 1988?
Offer a terse response. 25.32. What is the difference between the Net enrolment rate(%) of Latin America(all income levels) in 1987 and the Net enrolment rate(%) of Spain in 1988?
Keep it short and to the point. -9.8. What is the difference between the Net enrolment rate(%) of Latin America(all income levels) in 1987 and the Net enrolment rate(%) of Switzerland in 1988?
Keep it short and to the point. 10.52. What is the difference between the Net enrolment rate(%) in Oman in 1987 and the Net enrolment rate(%) in Spain in 1988?
Your response must be concise. -34.42. What is the difference between the Net enrolment rate(%) of Oman in 1987 and the Net enrolment rate(%) of Switzerland in 1988?
Offer a very short reply. -14.11. What is the difference between the Net enrolment rate(%) in Spain in 1987 and the Net enrolment rate(%) in Switzerland in 1988?
Provide a succinct answer. 19.92. What is the average Net enrolment rate(%) of Latin America(all income levels) per year?
Offer a terse response. 89.4. What is the average Net enrolment rate(%) in Oman per year?
Make the answer very short. 53.99. What is the average Net enrolment rate(%) in Spain per year?
Make the answer very short. 99.5. What is the average Net enrolment rate(%) of Switzerland per year?
Keep it short and to the point. 77.03. In the year 1978, what is the difference between the Net enrolment rate(%) in Latin America(all income levels) and Net enrolment rate(%) in Oman?
Your answer should be compact. 51.96. In the year 1978, what is the difference between the Net enrolment rate(%) in Latin America(all income levels) and Net enrolment rate(%) in Spain?
Give a very brief answer. -11.56. In the year 1978, what is the difference between the Net enrolment rate(%) in Latin America(all income levels) and Net enrolment rate(%) in Switzerland?
Your answer should be very brief. 10.55. In the year 1978, what is the difference between the Net enrolment rate(%) of Oman and Net enrolment rate(%) of Spain?
Provide a short and direct response. -63.52. In the year 1978, what is the difference between the Net enrolment rate(%) in Oman and Net enrolment rate(%) in Switzerland?
Your response must be concise. -41.4. In the year 1978, what is the difference between the Net enrolment rate(%) of Spain and Net enrolment rate(%) of Switzerland?
Offer a terse response. 22.11. In the year 1981, what is the difference between the Net enrolment rate(%) of Latin America(all income levels) and Net enrolment rate(%) of Oman?
Your response must be concise. 46.58. In the year 1981, what is the difference between the Net enrolment rate(%) in Latin America(all income levels) and Net enrolment rate(%) in Spain?
Offer a terse response. -9.72. In the year 1981, what is the difference between the Net enrolment rate(%) of Latin America(all income levels) and Net enrolment rate(%) of Switzerland?
Your answer should be very brief. 12.32. In the year 1981, what is the difference between the Net enrolment rate(%) of Oman and Net enrolment rate(%) of Spain?
Provide a succinct answer. -56.3. In the year 1981, what is the difference between the Net enrolment rate(%) of Oman and Net enrolment rate(%) of Switzerland?
Your answer should be very brief. -34.26. In the year 1981, what is the difference between the Net enrolment rate(%) of Spain and Net enrolment rate(%) of Switzerland?
Give a very brief answer. 22.04. In the year 1983, what is the difference between the Net enrolment rate(%) in Latin America(all income levels) and Net enrolment rate(%) in Oman?
Your answer should be very brief. 41.06. In the year 1983, what is the difference between the Net enrolment rate(%) of Latin America(all income levels) and Net enrolment rate(%) of Spain?
Ensure brevity in your answer.  -9.94. In the year 1983, what is the difference between the Net enrolment rate(%) of Latin America(all income levels) and Net enrolment rate(%) of Switzerland?
Your answer should be compact. 12.89. In the year 1983, what is the difference between the Net enrolment rate(%) of Oman and Net enrolment rate(%) of Spain?
Keep it short and to the point. -51. In the year 1983, what is the difference between the Net enrolment rate(%) of Oman and Net enrolment rate(%) of Switzerland?
Your answer should be compact. -28.18. In the year 1983, what is the difference between the Net enrolment rate(%) in Spain and Net enrolment rate(%) in Switzerland?
Keep it short and to the point. 22.83. In the year 1984, what is the difference between the Net enrolment rate(%) in Latin America(all income levels) and Net enrolment rate(%) in Oman?
Ensure brevity in your answer.  34.67. In the year 1984, what is the difference between the Net enrolment rate(%) in Latin America(all income levels) and Net enrolment rate(%) in Spain?
Provide a succinct answer. -10.13. In the year 1984, what is the difference between the Net enrolment rate(%) of Latin America(all income levels) and Net enrolment rate(%) of Switzerland?
Your answer should be very brief. 13.43. In the year 1984, what is the difference between the Net enrolment rate(%) in Oman and Net enrolment rate(%) in Spain?
Offer a terse response. -44.8. In the year 1984, what is the difference between the Net enrolment rate(%) of Oman and Net enrolment rate(%) of Switzerland?
Offer a terse response. -21.24. In the year 1984, what is the difference between the Net enrolment rate(%) in Spain and Net enrolment rate(%) in Switzerland?
Provide a short and direct response. 23.56. In the year 1985, what is the difference between the Net enrolment rate(%) in Latin America(all income levels) and Net enrolment rate(%) in Oman?
Keep it short and to the point. 32.59. In the year 1985, what is the difference between the Net enrolment rate(%) of Latin America(all income levels) and Net enrolment rate(%) of Spain?
Your response must be concise. -9.92. In the year 1985, what is the difference between the Net enrolment rate(%) of Latin America(all income levels) and Net enrolment rate(%) of Switzerland?
Ensure brevity in your answer.  13.82. In the year 1985, what is the difference between the Net enrolment rate(%) in Oman and Net enrolment rate(%) in Spain?
Provide a succinct answer. -42.51. In the year 1985, what is the difference between the Net enrolment rate(%) of Oman and Net enrolment rate(%) of Switzerland?
Offer a very short reply. -18.77. In the year 1985, what is the difference between the Net enrolment rate(%) of Spain and Net enrolment rate(%) of Switzerland?
Your response must be concise. 23.74. In the year 1986, what is the difference between the Net enrolment rate(%) in Latin America(all income levels) and Net enrolment rate(%) in Oman?
Offer a very short reply. 26.75. In the year 1986, what is the difference between the Net enrolment rate(%) in Latin America(all income levels) and Net enrolment rate(%) in Spain?
Provide a succinct answer. -10.02. In the year 1986, what is the difference between the Net enrolment rate(%) of Latin America(all income levels) and Net enrolment rate(%) of Switzerland?
Keep it short and to the point. 13.42. In the year 1986, what is the difference between the Net enrolment rate(%) of Oman and Net enrolment rate(%) of Spain?
Make the answer very short. -36.77. In the year 1986, what is the difference between the Net enrolment rate(%) in Oman and Net enrolment rate(%) in Switzerland?
Make the answer very short. -13.33. In the year 1986, what is the difference between the Net enrolment rate(%) in Spain and Net enrolment rate(%) in Switzerland?
Make the answer very short. 23.44. In the year 1987, what is the difference between the Net enrolment rate(%) in Latin America(all income levels) and Net enrolment rate(%) in Oman?
Make the answer very short. 24.62. In the year 1987, what is the difference between the Net enrolment rate(%) of Latin America(all income levels) and Net enrolment rate(%) of Spain?
Your response must be concise. -9.4. In the year 1987, what is the difference between the Net enrolment rate(%) in Latin America(all income levels) and Net enrolment rate(%) in Switzerland?
Offer a very short reply. 12.3. In the year 1987, what is the difference between the Net enrolment rate(%) in Oman and Net enrolment rate(%) in Spain?
Keep it short and to the point. -34.02. In the year 1987, what is the difference between the Net enrolment rate(%) in Oman and Net enrolment rate(%) in Switzerland?
Provide a short and direct response. -12.32. In the year 1987, what is the difference between the Net enrolment rate(%) of Spain and Net enrolment rate(%) of Switzerland?
Your response must be concise. 21.71. In the year 1988, what is the difference between the Net enrolment rate(%) of Latin America(all income levels) and Net enrolment rate(%) of Oman?
Your answer should be very brief. 25.08. In the year 1988, what is the difference between the Net enrolment rate(%) in Latin America(all income levels) and Net enrolment rate(%) in Spain?
Provide a short and direct response. -10.04. In the year 1988, what is the difference between the Net enrolment rate(%) in Latin America(all income levels) and Net enrolment rate(%) in Switzerland?
Provide a short and direct response. 10.27. In the year 1988, what is the difference between the Net enrolment rate(%) in Oman and Net enrolment rate(%) in Spain?
Provide a succinct answer. -35.12. In the year 1988, what is the difference between the Net enrolment rate(%) in Oman and Net enrolment rate(%) in Switzerland?
Provide a short and direct response. -14.81. In the year 1988, what is the difference between the Net enrolment rate(%) of Spain and Net enrolment rate(%) of Switzerland?
Provide a short and direct response. 20.31. What is the ratio of the Net enrolment rate(%) in Latin America(all income levels) in 1978 to that in 1981?
Your answer should be compact. 0.97. What is the ratio of the Net enrolment rate(%) in Oman in 1978 to that in 1981?
Ensure brevity in your answer.  0.81. What is the ratio of the Net enrolment rate(%) in Spain in 1978 to that in 1981?
Provide a short and direct response. 0.99. What is the ratio of the Net enrolment rate(%) in Switzerland in 1978 to that in 1981?
Your response must be concise. 0.99. What is the ratio of the Net enrolment rate(%) in Latin America(all income levels) in 1978 to that in 1983?
Your response must be concise. 0.97. What is the ratio of the Net enrolment rate(%) in Oman in 1978 to that in 1983?
Your response must be concise. 0.72. What is the ratio of the Net enrolment rate(%) in Spain in 1978 to that in 1983?
Provide a succinct answer. 0.99. What is the ratio of the Net enrolment rate(%) in Switzerland in 1978 to that in 1983?
Your answer should be compact. 0.99. What is the ratio of the Net enrolment rate(%) in Latin America(all income levels) in 1978 to that in 1984?
Ensure brevity in your answer.  0.97. What is the ratio of the Net enrolment rate(%) of Oman in 1978 to that in 1984?
Provide a succinct answer. 0.63. What is the ratio of the Net enrolment rate(%) in Spain in 1978 to that in 1984?
Give a very brief answer. 0.99. What is the ratio of the Net enrolment rate(%) of Switzerland in 1978 to that in 1984?
Provide a succinct answer. 1. What is the ratio of the Net enrolment rate(%) of Latin America(all income levels) in 1978 to that in 1985?
Your answer should be compact. 0.96. What is the ratio of the Net enrolment rate(%) in Oman in 1978 to that in 1985?
Your answer should be very brief. 0.61. What is the ratio of the Net enrolment rate(%) of Spain in 1978 to that in 1985?
Make the answer very short. 0.98. What is the ratio of the Net enrolment rate(%) of Latin America(all income levels) in 1978 to that in 1986?
Your response must be concise. 0.96. What is the ratio of the Net enrolment rate(%) of Oman in 1978 to that in 1986?
Provide a short and direct response. 0.55. What is the ratio of the Net enrolment rate(%) of Spain in 1978 to that in 1986?
Provide a succinct answer. 0.98. What is the ratio of the Net enrolment rate(%) in Latin America(all income levels) in 1978 to that in 1987?
Offer a very short reply. 0.96. What is the ratio of the Net enrolment rate(%) in Oman in 1978 to that in 1987?
Provide a succinct answer. 0.53. What is the ratio of the Net enrolment rate(%) of Spain in 1978 to that in 1987?
Make the answer very short. 0.99. What is the ratio of the Net enrolment rate(%) in Latin America(all income levels) in 1978 to that in 1988?
Make the answer very short. 0.97. What is the ratio of the Net enrolment rate(%) in Oman in 1978 to that in 1988?
Keep it short and to the point. 0.54. What is the ratio of the Net enrolment rate(%) in Spain in 1978 to that in 1988?
Make the answer very short. 0.98. What is the ratio of the Net enrolment rate(%) in Switzerland in 1978 to that in 1988?
Your answer should be compact. 0.96. What is the ratio of the Net enrolment rate(%) in Latin America(all income levels) in 1981 to that in 1983?
Make the answer very short. 1. What is the ratio of the Net enrolment rate(%) of Oman in 1981 to that in 1983?
Your answer should be compact. 0.88. What is the ratio of the Net enrolment rate(%) of Switzerland in 1981 to that in 1983?
Your answer should be compact. 1.01. What is the ratio of the Net enrolment rate(%) in Oman in 1981 to that in 1984?
Ensure brevity in your answer.  0.78. What is the ratio of the Net enrolment rate(%) of Spain in 1981 to that in 1984?
Offer a terse response. 0.99. What is the ratio of the Net enrolment rate(%) in Switzerland in 1981 to that in 1984?
Give a very brief answer. 1.01. What is the ratio of the Net enrolment rate(%) in Oman in 1981 to that in 1985?
Provide a succinct answer. 0.75. What is the ratio of the Net enrolment rate(%) in Spain in 1981 to that in 1985?
Make the answer very short. 0.99. What is the ratio of the Net enrolment rate(%) in Switzerland in 1981 to that in 1985?
Offer a terse response. 1.01. What is the ratio of the Net enrolment rate(%) in Oman in 1981 to that in 1986?
Your response must be concise. 0.68. What is the ratio of the Net enrolment rate(%) in Spain in 1981 to that in 1986?
Your response must be concise. 0.99. What is the ratio of the Net enrolment rate(%) of Switzerland in 1981 to that in 1986?
Your response must be concise. 1.01. What is the ratio of the Net enrolment rate(%) in Latin America(all income levels) in 1981 to that in 1987?
Your answer should be compact. 0.99. What is the ratio of the Net enrolment rate(%) of Oman in 1981 to that in 1987?
Keep it short and to the point. 0.66. What is the ratio of the Net enrolment rate(%) in Switzerland in 1981 to that in 1987?
Provide a short and direct response. 0.99. What is the ratio of the Net enrolment rate(%) in Latin America(all income levels) in 1981 to that in 1988?
Your response must be concise. 1. What is the ratio of the Net enrolment rate(%) in Oman in 1981 to that in 1988?
Give a very brief answer. 0.66. What is the ratio of the Net enrolment rate(%) in Switzerland in 1981 to that in 1988?
Your answer should be compact. 0.97. What is the ratio of the Net enrolment rate(%) of Latin America(all income levels) in 1983 to that in 1984?
Give a very brief answer. 1. What is the ratio of the Net enrolment rate(%) in Oman in 1983 to that in 1984?
Offer a terse response. 0.88. What is the ratio of the Net enrolment rate(%) of Spain in 1983 to that in 1984?
Your response must be concise. 1. What is the ratio of the Net enrolment rate(%) in Switzerland in 1983 to that in 1984?
Your answer should be very brief. 1.01. What is the ratio of the Net enrolment rate(%) of Latin America(all income levels) in 1983 to that in 1985?
Ensure brevity in your answer.  1. What is the ratio of the Net enrolment rate(%) in Oman in 1983 to that in 1985?
Your answer should be compact. 0.85. What is the ratio of the Net enrolment rate(%) of Switzerland in 1983 to that in 1985?
Offer a terse response. 1.01. What is the ratio of the Net enrolment rate(%) of Latin America(all income levels) in 1983 to that in 1986?
Keep it short and to the point. 1. What is the ratio of the Net enrolment rate(%) in Oman in 1983 to that in 1986?
Your answer should be very brief. 0.77. What is the ratio of the Net enrolment rate(%) of Spain in 1983 to that in 1986?
Provide a succinct answer. 1. What is the ratio of the Net enrolment rate(%) of Switzerland in 1983 to that in 1986?
Provide a short and direct response. 1. What is the ratio of the Net enrolment rate(%) in Oman in 1983 to that in 1987?
Ensure brevity in your answer.  0.74. What is the ratio of the Net enrolment rate(%) of Spain in 1983 to that in 1987?
Offer a very short reply. 1. What is the ratio of the Net enrolment rate(%) of Switzerland in 1983 to that in 1987?
Offer a terse response. 0.99. What is the ratio of the Net enrolment rate(%) in Latin America(all income levels) in 1983 to that in 1988?
Your response must be concise. 1. What is the ratio of the Net enrolment rate(%) of Oman in 1983 to that in 1988?
Keep it short and to the point. 0.75. What is the ratio of the Net enrolment rate(%) in Spain in 1983 to that in 1988?
Offer a terse response. 1. What is the ratio of the Net enrolment rate(%) in Switzerland in 1983 to that in 1988?
Make the answer very short. 0.96. What is the ratio of the Net enrolment rate(%) in Oman in 1984 to that in 1985?
Offer a very short reply. 0.96. What is the ratio of the Net enrolment rate(%) of Spain in 1984 to that in 1985?
Your response must be concise. 1. What is the ratio of the Net enrolment rate(%) of Oman in 1984 to that in 1986?
Offer a terse response. 0.87. What is the ratio of the Net enrolment rate(%) of Spain in 1984 to that in 1986?
Your answer should be very brief. 1. What is the ratio of the Net enrolment rate(%) in Oman in 1984 to that in 1987?
Offer a very short reply. 0.84. What is the ratio of the Net enrolment rate(%) of Switzerland in 1984 to that in 1987?
Your answer should be compact. 0.98. What is the ratio of the Net enrolment rate(%) of Oman in 1984 to that in 1988?
Keep it short and to the point. 0.85. What is the ratio of the Net enrolment rate(%) of Switzerland in 1984 to that in 1988?
Your response must be concise. 0.96. What is the ratio of the Net enrolment rate(%) in Latin America(all income levels) in 1985 to that in 1986?
Make the answer very short. 1. What is the ratio of the Net enrolment rate(%) of Oman in 1985 to that in 1986?
Provide a short and direct response. 0.91. What is the ratio of the Net enrolment rate(%) of Switzerland in 1985 to that in 1986?
Offer a terse response. 0.99. What is the ratio of the Net enrolment rate(%) of Latin America(all income levels) in 1985 to that in 1987?
Make the answer very short. 1. What is the ratio of the Net enrolment rate(%) of Oman in 1985 to that in 1987?
Ensure brevity in your answer.  0.88. What is the ratio of the Net enrolment rate(%) in Switzerland in 1985 to that in 1987?
Offer a terse response. 0.98. What is the ratio of the Net enrolment rate(%) of Latin America(all income levels) in 1985 to that in 1988?
Offer a very short reply. 1. What is the ratio of the Net enrolment rate(%) in Oman in 1985 to that in 1988?
Your answer should be compact. 0.89. What is the ratio of the Net enrolment rate(%) of Switzerland in 1985 to that in 1988?
Ensure brevity in your answer.  0.96. What is the ratio of the Net enrolment rate(%) in Oman in 1986 to that in 1987?
Your answer should be compact. 0.97. What is the ratio of the Net enrolment rate(%) in Spain in 1986 to that in 1987?
Provide a succinct answer. 1.01. What is the ratio of the Net enrolment rate(%) in Switzerland in 1986 to that in 1987?
Offer a very short reply. 0.98. What is the ratio of the Net enrolment rate(%) in Spain in 1986 to that in 1988?
Your answer should be compact. 1. What is the ratio of the Net enrolment rate(%) of Switzerland in 1986 to that in 1988?
Offer a terse response. 0.96. What is the ratio of the Net enrolment rate(%) of Latin America(all income levels) in 1987 to that in 1988?
Make the answer very short. 1. What is the ratio of the Net enrolment rate(%) of Oman in 1987 to that in 1988?
Offer a terse response. 1.01. What is the ratio of the Net enrolment rate(%) of Switzerland in 1987 to that in 1988?
Make the answer very short. 0.98. What is the difference between the highest and the second highest Net enrolment rate(%) in Latin America(all income levels)?
Your answer should be very brief. 0.06. What is the difference between the highest and the second highest Net enrolment rate(%) in Oman?
Provide a short and direct response. 0.7. What is the difference between the highest and the second highest Net enrolment rate(%) in Spain?
Offer a terse response. 0.11. What is the difference between the highest and the second highest Net enrolment rate(%) of Switzerland?
Ensure brevity in your answer.  1.79. What is the difference between the highest and the lowest Net enrolment rate(%) in Latin America(all income levels)?
Give a very brief answer. 3.3. What is the difference between the highest and the lowest Net enrolment rate(%) of Oman?
Give a very brief answer. 30.64. What is the difference between the highest and the lowest Net enrolment rate(%) of Spain?
Ensure brevity in your answer.  1.7. What is the difference between the highest and the lowest Net enrolment rate(%) in Switzerland?
Your answer should be compact. 3.38. 